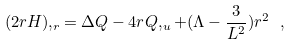Convert formula to latex. <formula><loc_0><loc_0><loc_500><loc_500>( 2 r H ) , _ { r } = \Delta Q - 4 r Q , _ { u } + ( \Lambda - \frac { 3 } { L ^ { 2 } } ) r ^ { 2 } \ ,</formula> 